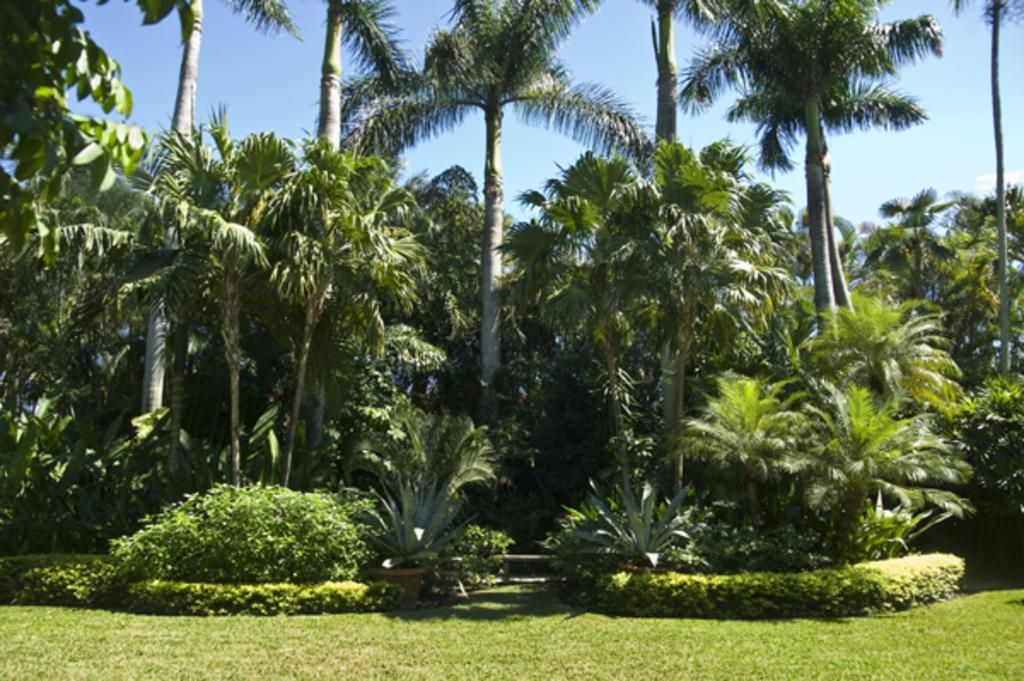What type of natural environment is depicted in the image? There are many plants and grass in the image, suggesting a natural setting. What can be seen in the sky in the image? The sky is visible in the image. Are there any weather conditions indicated by the sky? There is a cloud in the image, which suggests that there might be some weather conditions present. What type of class is being held in the image? There is no class present in the image; it features a natural environment with plants, grass, and a cloudy sky. 